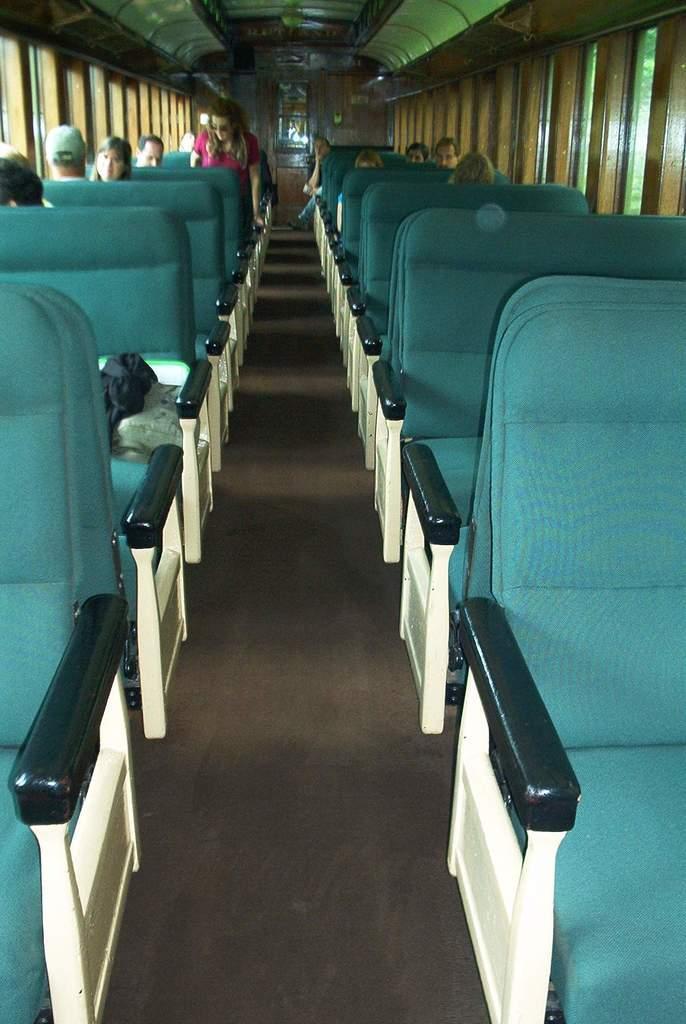How would you summarize this image in a sentence or two? It is the image captured inside some vehicle, most of the seats are empty in the front and the last seats were occupied and there is a wooden wall in the background and in between the wall there is a glass. 